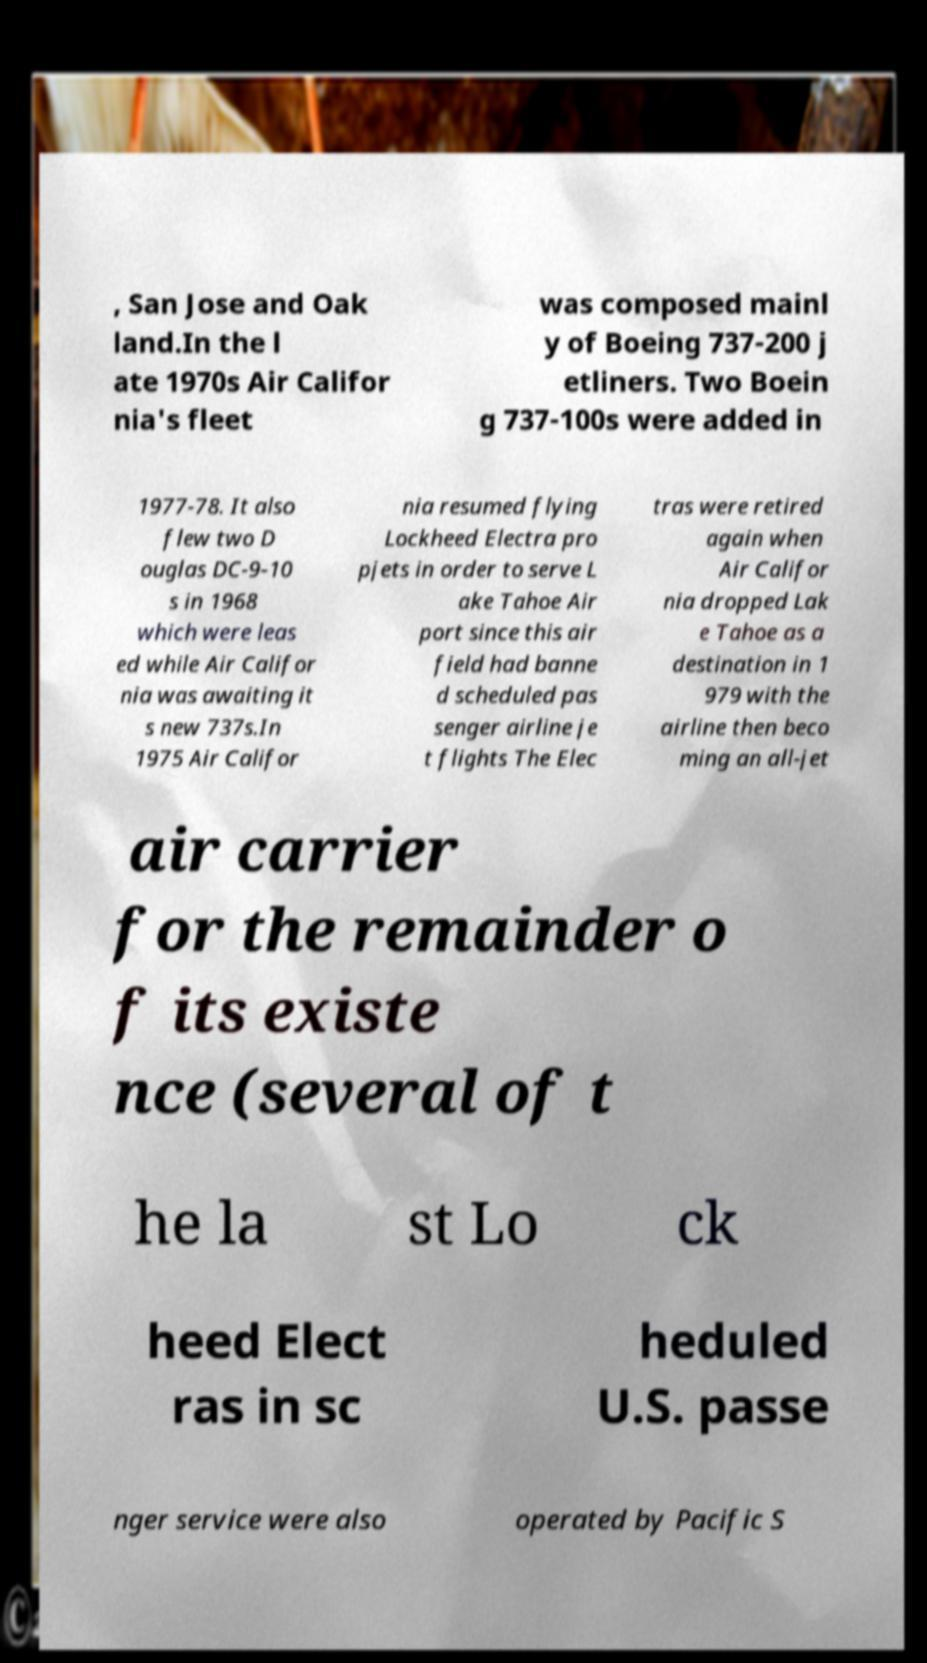What messages or text are displayed in this image? I need them in a readable, typed format. , San Jose and Oak land.In the l ate 1970s Air Califor nia's fleet was composed mainl y of Boeing 737-200 j etliners. Two Boein g 737-100s were added in 1977-78. It also flew two D ouglas DC-9-10 s in 1968 which were leas ed while Air Califor nia was awaiting it s new 737s.In 1975 Air Califor nia resumed flying Lockheed Electra pro pjets in order to serve L ake Tahoe Air port since this air field had banne d scheduled pas senger airline je t flights The Elec tras were retired again when Air Califor nia dropped Lak e Tahoe as a destination in 1 979 with the airline then beco ming an all-jet air carrier for the remainder o f its existe nce (several of t he la st Lo ck heed Elect ras in sc heduled U.S. passe nger service were also operated by Pacific S 